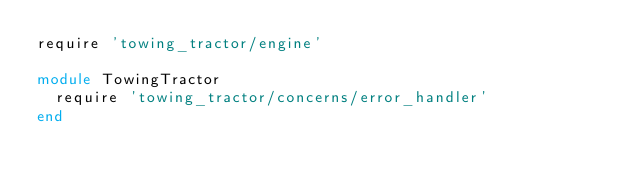Convert code to text. <code><loc_0><loc_0><loc_500><loc_500><_Ruby_>require 'towing_tractor/engine'

module TowingTractor
  require 'towing_tractor/concerns/error_handler'
end
</code> 